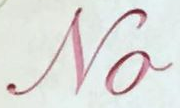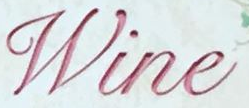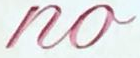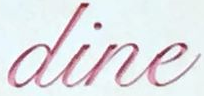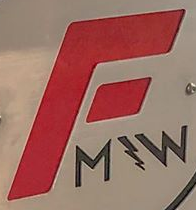Read the text content from these images in order, separated by a semicolon. No; Wine; no; dine; F 